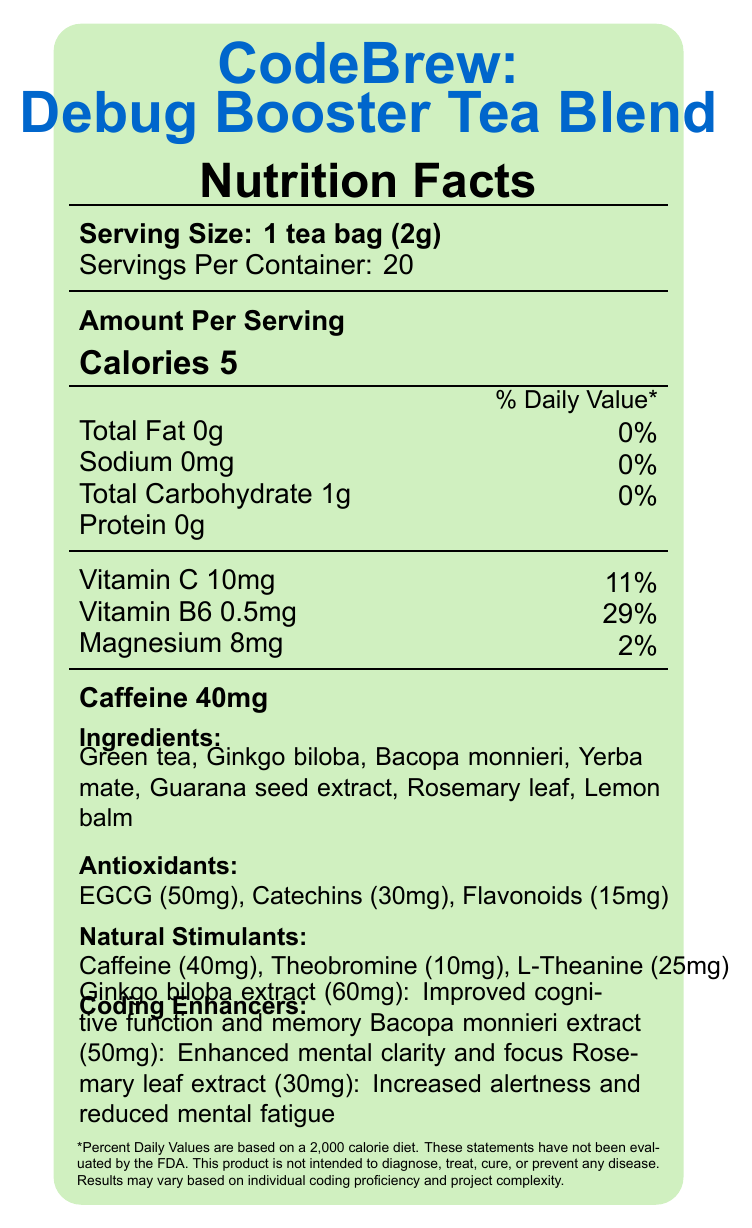what is the serving size for CodeBrew: Debug Booster Tea Blend? The document states that the serving size is 1 tea bag weighing 2 grams.
Answer: 1 tea bag (2g) how many servings are there per container? The label specifies that there are 20 servings per container.
Answer: 20 what is the total carbohydrate amount per serving? The document lists the total carbohydrate amount as 1 gram per serving.
Answer: 1g what percent of daily value is Vitamin B6 per serving? The document shows that Vitamin B6 contributes to 29% of the daily value per serving.
Answer: 29% name two ingredients in the tea blend that are labeled as coding enhancers. The label lists Ginkgo biloba extract and Bacopa monnieri extract under coding enhancers.
Answer: Ginkgo biloba extract and Bacopa monnieri extract which of the following antioxidants is present in the largest amount? A. Catechins B. Flavonoids C. EGCG D. Vitamin C The document lists EGCG at 50mg, Catechins at 30mg, and Flavonoids at 15mg, making EGCG the most abundant.
Answer: C. EGCG what is the amount of caffeine in one serving of the tea blend? A. 20mg B. 30mg C. 40mg D. 50mg The document states that each serving of the tea blend contains 40mg of caffeine.
Answer: C. 40mg does the product contain any protein? The document clearly states that the protein content per serving is 0g.
Answer: No briefly describe the main purpose and benefits of consuming CodeBrew: Debug Booster Tea Blend. The document highlights the use of specific ingredients like Ginkgo biloba and Bacopa monnieri for cognitive benefits and natural stimulants like caffeine to aid in mental performance during coding sessions.
Answer: The tea blend is marketed to improve code debugging skills by highlighting antioxidants and natural stimulants, and it contains ingredients aimed at enhancing cognitive function, memory, mental clarity, and focus. what are the storage instructions for the tea blend? The label advises keeping the product in a cool, dry place away from direct sunlight and electromagnetic fields.
Answer: Store in a cool, dry place away from direct sunlight and electromagnetic fields. what is the benefit of Bacopa monnieri extract according to the document? The document specifies that Bacopa monnieri extract is listed under coding enhancers with the benefit of enhanced mental clarity and focus.
Answer: Enhanced mental clarity and focus what is the sodium content per serving? The label states that the sodium content per serving is 0mg.
Answer: 0mg which company manufactures CodeBrew: Debug Booster Tea Blend? The document lists the manufacturer's name as ByteBrew Innovations, Inc.
Answer: ByteBrew Innovations, Inc. where is ByteBrew Innovations, Inc. located? A. New York, NY B. Silicon Valley, CA C. Austin, TX The label provides the address as 1024 Algorithm Avenue, Silicon Valley, CA 94024.
Answer: B. Silicon Valley, CA does the tea blend have any flavoring ingredients? The document does not provide any information specifically listing flavoring ingredients.
Answer: Not enough information how should the tea blend be brewed for best results? The brewing instructions recommend steeping the tea for 3-5 minutes in hot water at 80°C/176°F and consuming it during coding or debugging for best results.
Answer: Steep for 3-5 minutes in hot water (80°C/176°F) and consume while reviewing code or during intense debugging sessions. 